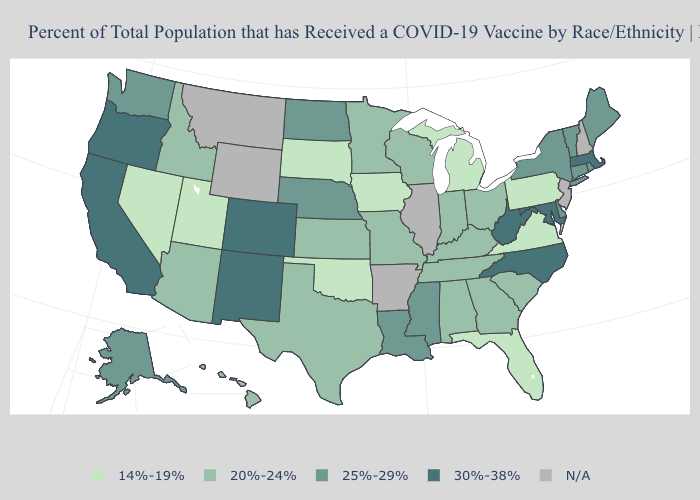Name the states that have a value in the range 14%-19%?
Give a very brief answer. Florida, Iowa, Michigan, Nevada, Oklahoma, Pennsylvania, South Dakota, Utah, Virginia. Does Massachusetts have the highest value in the Northeast?
Write a very short answer. Yes. Does the map have missing data?
Be succinct. Yes. What is the value of Minnesota?
Answer briefly. 20%-24%. What is the highest value in the South ?
Short answer required. 30%-38%. Name the states that have a value in the range N/A?
Write a very short answer. Arkansas, Illinois, Montana, New Hampshire, New Jersey, Wyoming. Name the states that have a value in the range 14%-19%?
Quick response, please. Florida, Iowa, Michigan, Nevada, Oklahoma, Pennsylvania, South Dakota, Utah, Virginia. Among the states that border Utah , which have the lowest value?
Answer briefly. Nevada. What is the lowest value in the MidWest?
Write a very short answer. 14%-19%. What is the value of Wyoming?
Short answer required. N/A. What is the value of Nebraska?
Answer briefly. 25%-29%. What is the value of Illinois?
Write a very short answer. N/A. Name the states that have a value in the range N/A?
Write a very short answer. Arkansas, Illinois, Montana, New Hampshire, New Jersey, Wyoming. What is the value of Nevada?
Concise answer only. 14%-19%. Is the legend a continuous bar?
Short answer required. No. 